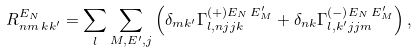<formula> <loc_0><loc_0><loc_500><loc_500>R _ { n m \, k k ^ { \prime } } ^ { E _ { N } } = \sum _ { l } \sum _ { M , E ^ { \prime } , j } \left ( \delta _ { m k ^ { \prime } } \Gamma _ { l , n j j k } ^ { ( + ) E _ { N } \, E ^ { \prime } _ { M } } + \delta _ { n k } \Gamma _ { l , k ^ { \prime } j j m } ^ { ( - ) E _ { N } \, E ^ { \prime } _ { M } } \right ) ,</formula> 